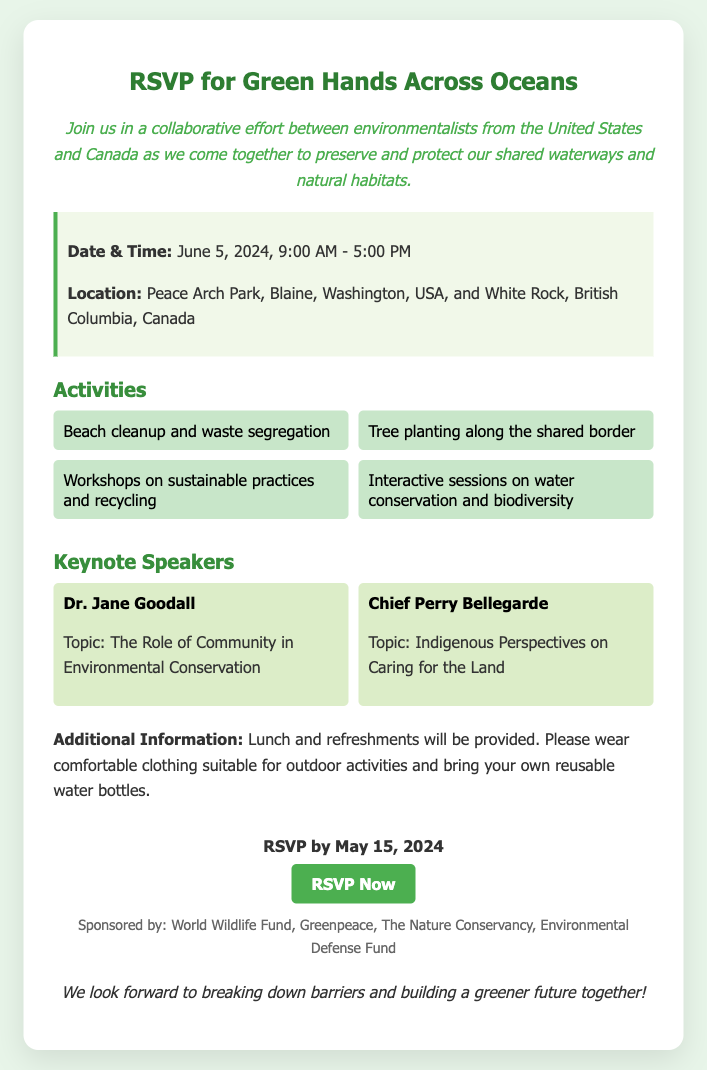What is the date of the event? The event is scheduled for June 5, 2024, as mentioned in the details.
Answer: June 5, 2024 Where is the event located? The location is specified as Peace Arch Park, Blaine, Washington, USA, and White Rock, British Columbia, Canada.
Answer: Peace Arch Park What time does the event start? The start time is indicated in the details, which states it begins at 9:00 AM.
Answer: 9:00 AM Who is one of the keynote speakers? The document lists Dr. Jane Goodall as one of the keynote speakers.
Answer: Dr. Jane Goodall What is one of the activities planned for the event? The activities include beach cleanup and waste segregation.
Answer: Beach cleanup and waste segregation What is the RSVP deadline? The deadline for RSVP is stated clearly, which is May 15, 2024.
Answer: May 15, 2024 What will be provided for attendees? The document mentions that lunch and refreshments will be provided.
Answer: Lunch and refreshments What is the purpose of the event? The purpose is to preserve and protect shared waterways and natural habitats, as articulated in the introduction.
Answer: Preserve and protect shared waterways What should attendees bring? Attendees are asked to bring their own reusable water bottles as indicated in the additional information section.
Answer: Reusable water bottles 